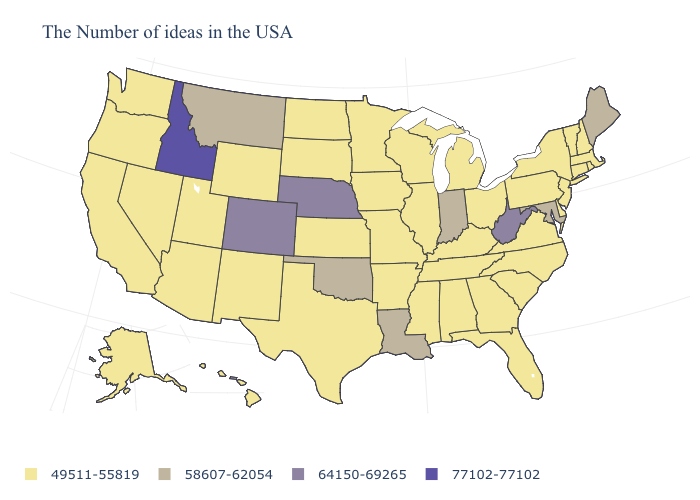Is the legend a continuous bar?
Write a very short answer. No. Name the states that have a value in the range 64150-69265?
Quick response, please. West Virginia, Nebraska, Colorado. What is the value of South Dakota?
Keep it brief. 49511-55819. What is the value of Tennessee?
Be succinct. 49511-55819. Which states have the highest value in the USA?
Be succinct. Idaho. What is the value of Indiana?
Give a very brief answer. 58607-62054. Among the states that border North Carolina , which have the lowest value?
Give a very brief answer. Virginia, South Carolina, Georgia, Tennessee. Does Missouri have a lower value than Kentucky?
Be succinct. No. How many symbols are there in the legend?
Concise answer only. 4. What is the value of Massachusetts?
Answer briefly. 49511-55819. What is the value of Alabama?
Write a very short answer. 49511-55819. Does West Virginia have the lowest value in the South?
Concise answer only. No. Name the states that have a value in the range 77102-77102?
Write a very short answer. Idaho. Does the map have missing data?
Write a very short answer. No. 